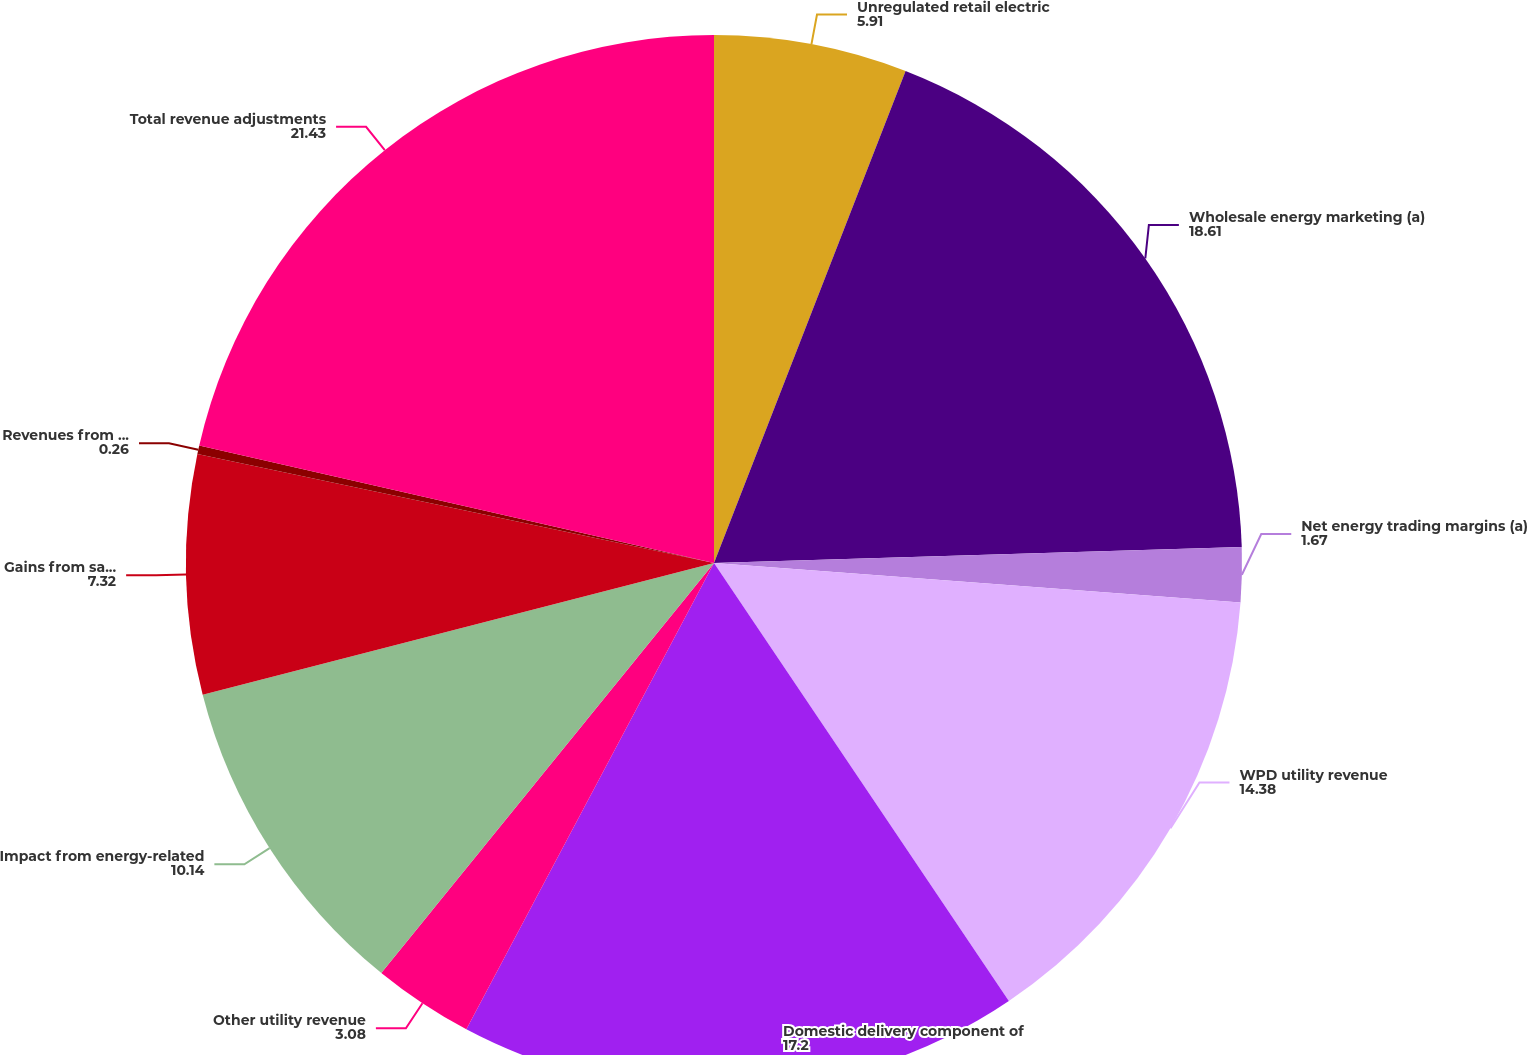Convert chart. <chart><loc_0><loc_0><loc_500><loc_500><pie_chart><fcel>Unregulated retail electric<fcel>Wholesale energy marketing (a)<fcel>Net energy trading margins (a)<fcel>WPD utility revenue<fcel>Domestic delivery component of<fcel>Other utility revenue<fcel>Impact from energy-related<fcel>Gains from sale of emission<fcel>Revenues from Supply segment<fcel>Total revenue adjustments<nl><fcel>5.91%<fcel>18.61%<fcel>1.67%<fcel>14.38%<fcel>17.2%<fcel>3.08%<fcel>10.14%<fcel>7.32%<fcel>0.26%<fcel>21.43%<nl></chart> 